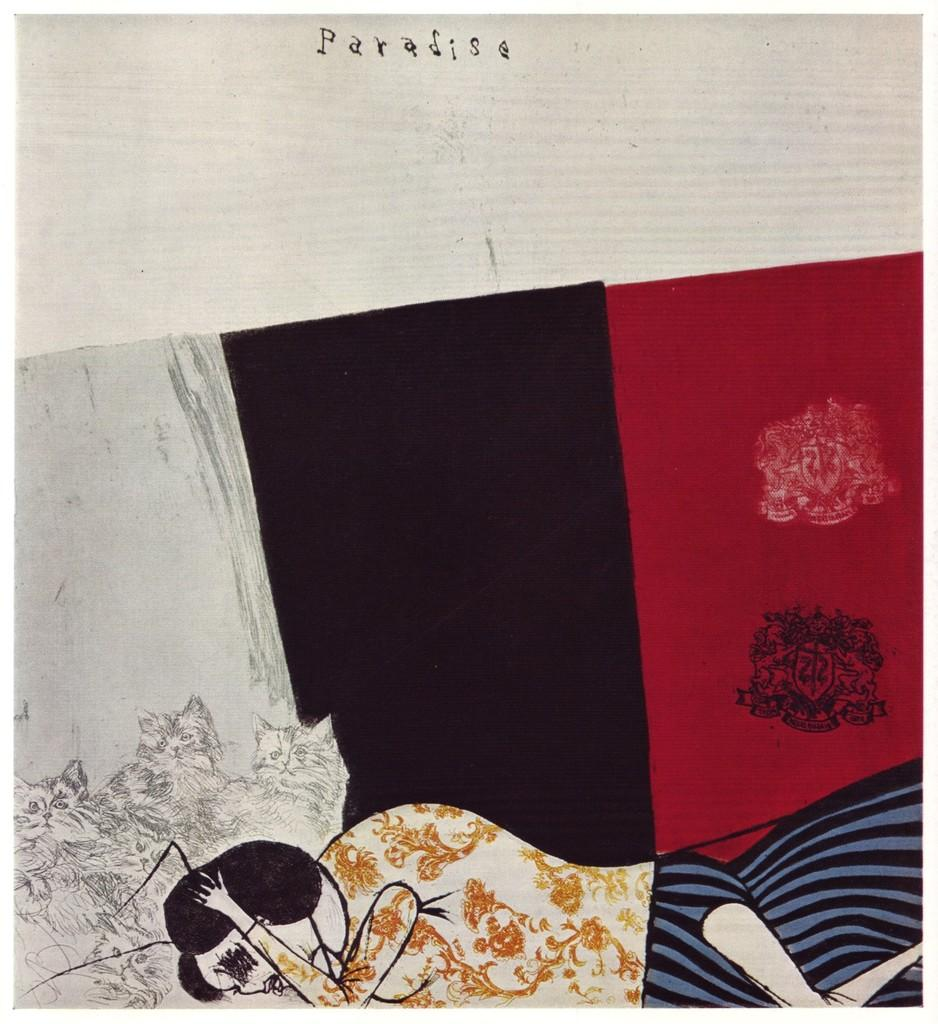What type of art is depicted in the image? The image is a pencil art. Who or what is the main subject of the art? The art features a woman and cats. Can you describe any patterns or designs in the image? Yes, there is a design in the image. Are there any words or letters in the image? Yes, there are letters in the image. What is the process of building a town in the image? There is no town or building process depicted in the image; it features a woman and cats in a pencil art design. How many women are present in the image? The image features a single woman, not multiple women. 